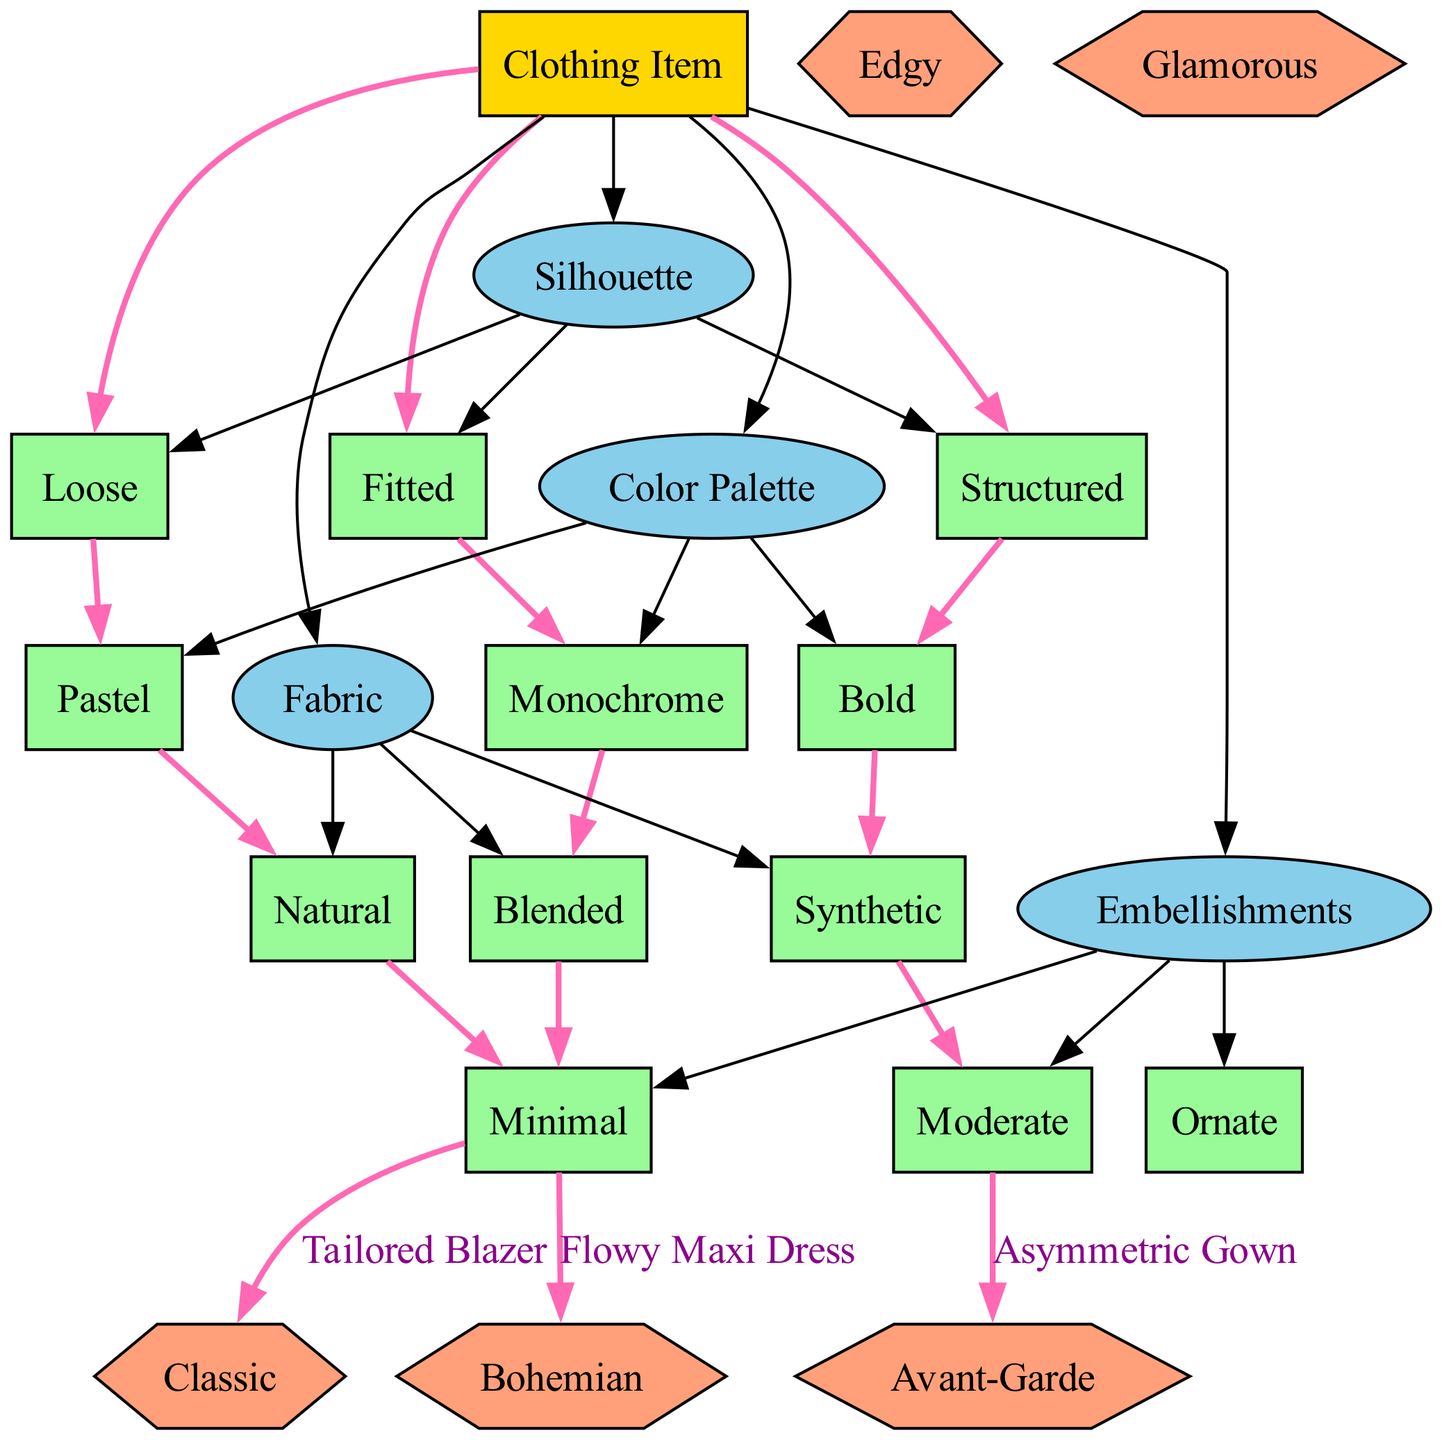What is the root node of the diagram? The root node is labeled 'Clothing Item', which indicates the starting point for classifying clothing items based on their visual attributes.
Answer: Clothing Item How many attributes are there in the diagram? There are four attributes listed: Silhouette, Color Palette, Fabric, and Embellishments, indicating that the classification will be based on these four aspects.
Answer: 4 Which category is associated with the item "Flowy Maxi Dress"? The path for "Flowy Maxi Dress" leads through the nodes for Loose, Pastel, Natural, and Minimal, and the final category reached is Bohemian.
Answer: Bohemian What is the color palette option for the item "Asymmetric Gown"? The path for "Asymmetric Gown" includes the node for Bold under the Color Palette attribute, indicating that its color scheme is bold.
Answer: Bold Which clothing item falls under the category "Classic"? By tracing the path for Tailored Blazer, it ends in the Classic category, confirming that this item fits that style classification.
Answer: Tailored Blazer How many total categories are available in the diagram? There are five categories shown: Avant-Garde, Bohemian, Classic, Edgy, and Glamorous, which means the clothing items can be classified into any of these styles.
Answer: 5 What type of node is used to represent categories in the diagram? The categories are represented as hexagonal nodes, which differentiates them from the elliptical and rectangular nodes used for attributes and the root, respectively.
Answer: Hexagon What embellishment option corresponds to the "Tailored Blazer"? The classification path for "Tailored Blazer" includes the node for Minimal under the Embellishments attribute, indicating its embellishment style.
Answer: Minimal Which attribute has the option "Structured"? The option "Structured" is part of the Silhouette attribute, indicating that it describes a specific type of shape for clothing items.
Answer: Silhouette 